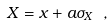<formula> <loc_0><loc_0><loc_500><loc_500>X = x + a \sigma _ { X } \ ,</formula> 